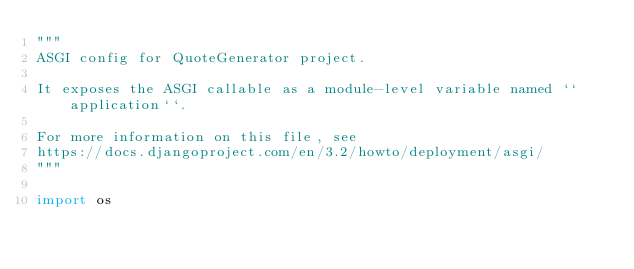<code> <loc_0><loc_0><loc_500><loc_500><_Python_>"""
ASGI config for QuoteGenerator project.

It exposes the ASGI callable as a module-level variable named ``application``.

For more information on this file, see
https://docs.djangoproject.com/en/3.2/howto/deployment/asgi/
"""

import os
</code> 